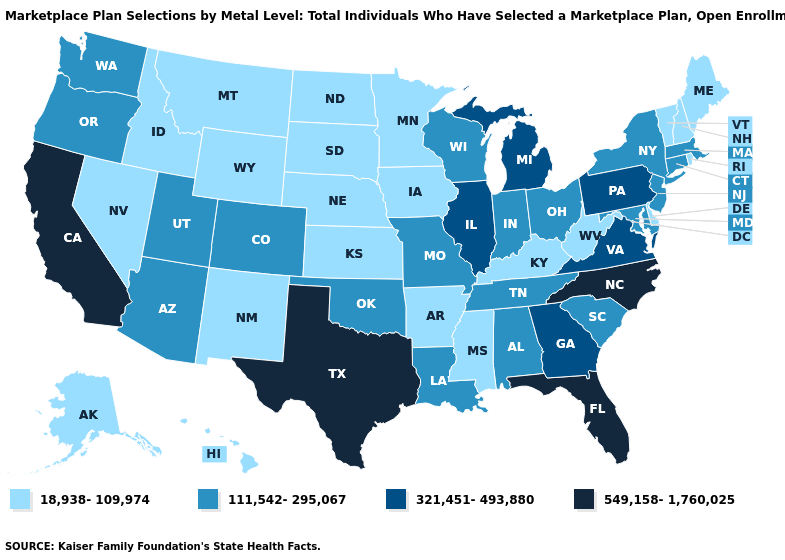What is the value of Indiana?
Keep it brief. 111,542-295,067. What is the value of Oklahoma?
Quick response, please. 111,542-295,067. Name the states that have a value in the range 111,542-295,067?
Answer briefly. Alabama, Arizona, Colorado, Connecticut, Indiana, Louisiana, Maryland, Massachusetts, Missouri, New Jersey, New York, Ohio, Oklahoma, Oregon, South Carolina, Tennessee, Utah, Washington, Wisconsin. What is the value of North Dakota?
Give a very brief answer. 18,938-109,974. Which states have the lowest value in the MidWest?
Answer briefly. Iowa, Kansas, Minnesota, Nebraska, North Dakota, South Dakota. What is the value of Virginia?
Quick response, please. 321,451-493,880. Which states have the highest value in the USA?
Concise answer only. California, Florida, North Carolina, Texas. Which states have the lowest value in the West?
Answer briefly. Alaska, Hawaii, Idaho, Montana, Nevada, New Mexico, Wyoming. What is the lowest value in states that border Virginia?
Answer briefly. 18,938-109,974. Is the legend a continuous bar?
Keep it brief. No. Does Washington have a lower value than Alabama?
Keep it brief. No. What is the value of Wyoming?
Write a very short answer. 18,938-109,974. How many symbols are there in the legend?
Answer briefly. 4. Does the first symbol in the legend represent the smallest category?
Keep it brief. Yes. Among the states that border South Carolina , does Georgia have the highest value?
Concise answer only. No. 